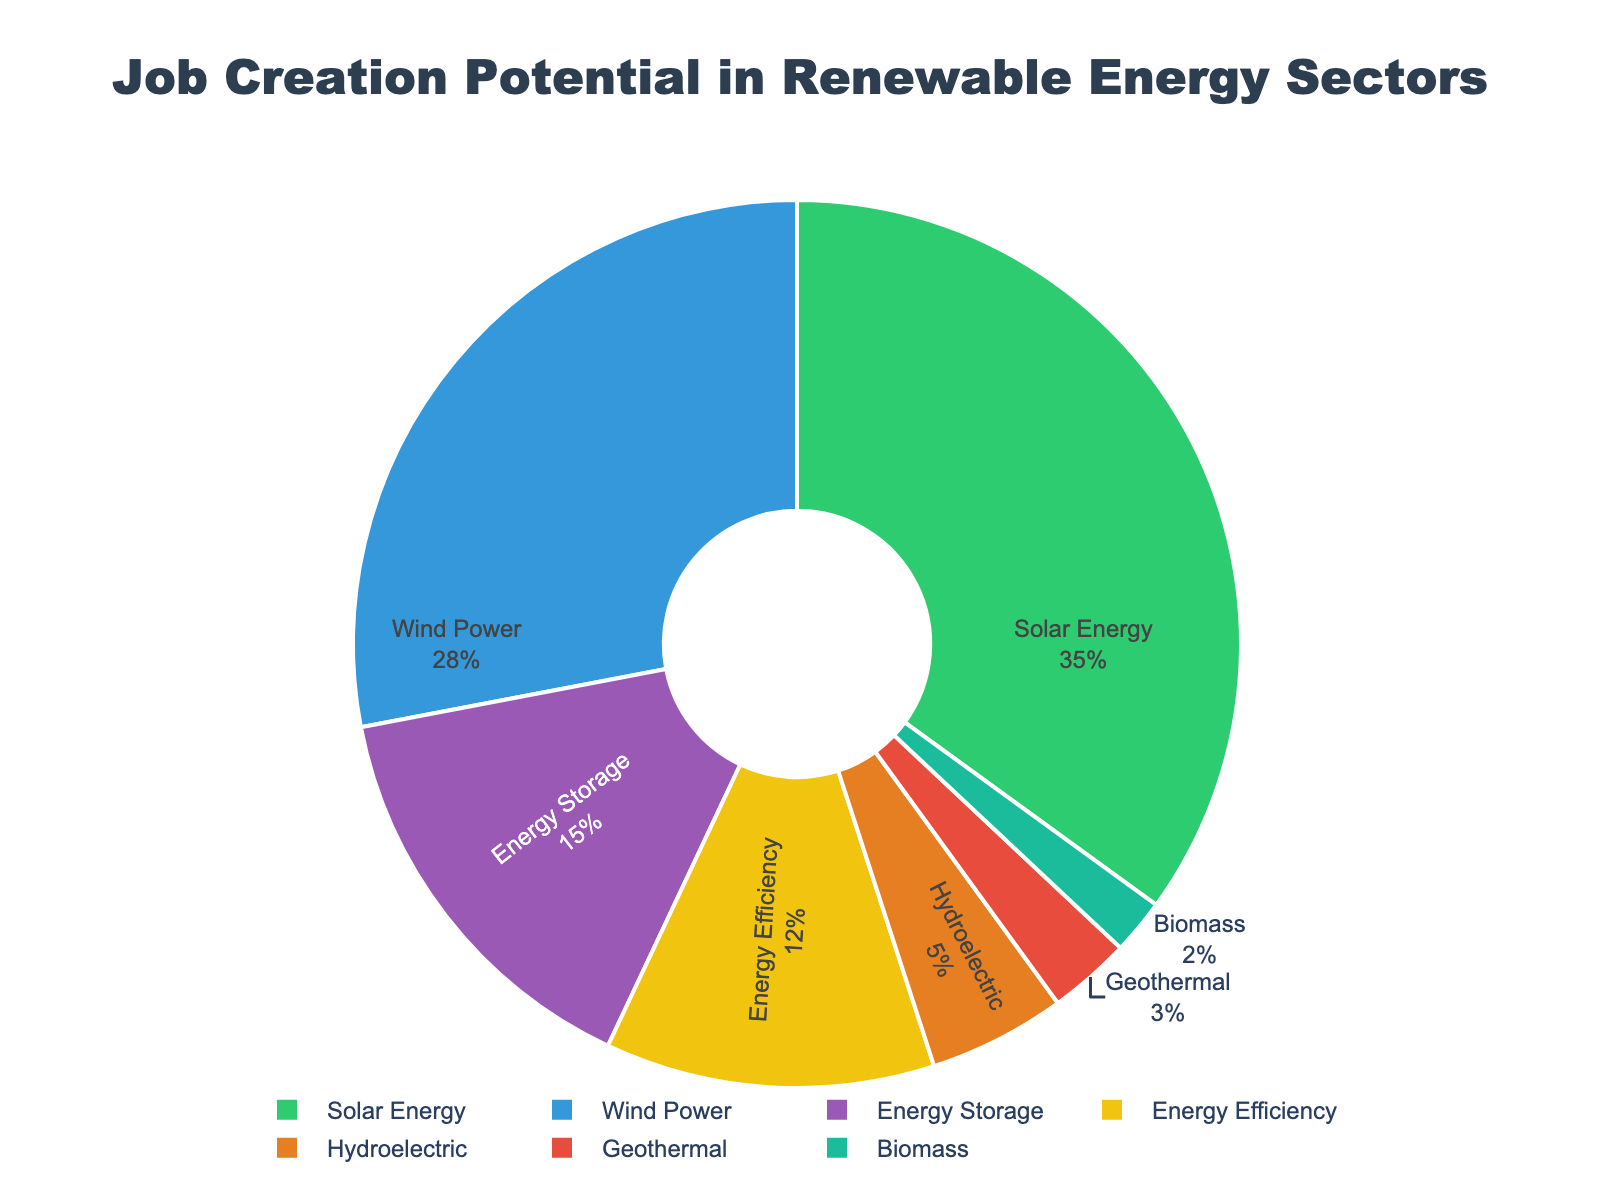Which renewable energy sector has the highest job creation potential? The sector with the highest job creation potential is identified by the largest segment in the pie chart. From the chart, Solar Energy appears to have the largest segment.
Answer: Solar Energy Which sector has the second highest job creation potential? The sector with the second highest job creation potential is identified by the segment that is second largest in size after the first. In the chart, Wind Power has the second largest segment.
Answer: Wind Power How much job creation potential does the least contributing sector have? The sector with the least job creation potential is the smallest segment in the pie chart. From the chart, Biomass has the smallest segment with 2% job creation potential.
Answer: 2% What is the combined job creation potential of Energy Storage and Energy Efficiency sectors? To find the combined job creation potential, sum the percentages of the Energy Storage and Energy Efficiency segments. From the chart, Energy Storage has 15% and Energy Efficiency has 12%. So, 15% + 12% = 27%.
Answer: 27% Is the job creation potential of Hydroelectric greater than Geothermal? Compare the segments for Hydroelectric and Geothermal. From the chart, Hydroelectric appears to have a larger segment than Geothermal.
Answer: Yes What percentage of job creation potential is from sectors other than Solar Energy? Subtract the percentage of Solar Energy from 100%. From the chart, Solar Energy has 35%. So, 100% - 35% = 65%.
Answer: 65% Which sector appears in green color, and what is its job creation potential? Identify the sector corresponding to the green-colored segment in the pie chart. From the chart, Solar Energy is in green and has a job creation potential of 35%.
Answer: Solar Energy, 35% Is the job creation potential of Solar Energy more than Energy Storage and Wind Power combined? Sum the percentages of Energy Storage and Wind Power, and compare the result with Solar Energy. From the chart, Energy Storage has 15% and Wind Power has 28%. Their combined total is 15% + 28% = 43%, which is greater than Solar Energy's 35%.
Answer: No What is the difference in job creation potential between Wind Power and Energy Efficiency sectors? Subtract the percentage of Energy Efficiency from the percentage of Wind Power. From the chart, Wind Power has 28% and Energy Efficiency has 12%. So, 28% - 12% = 16%.
Answer: 16% 